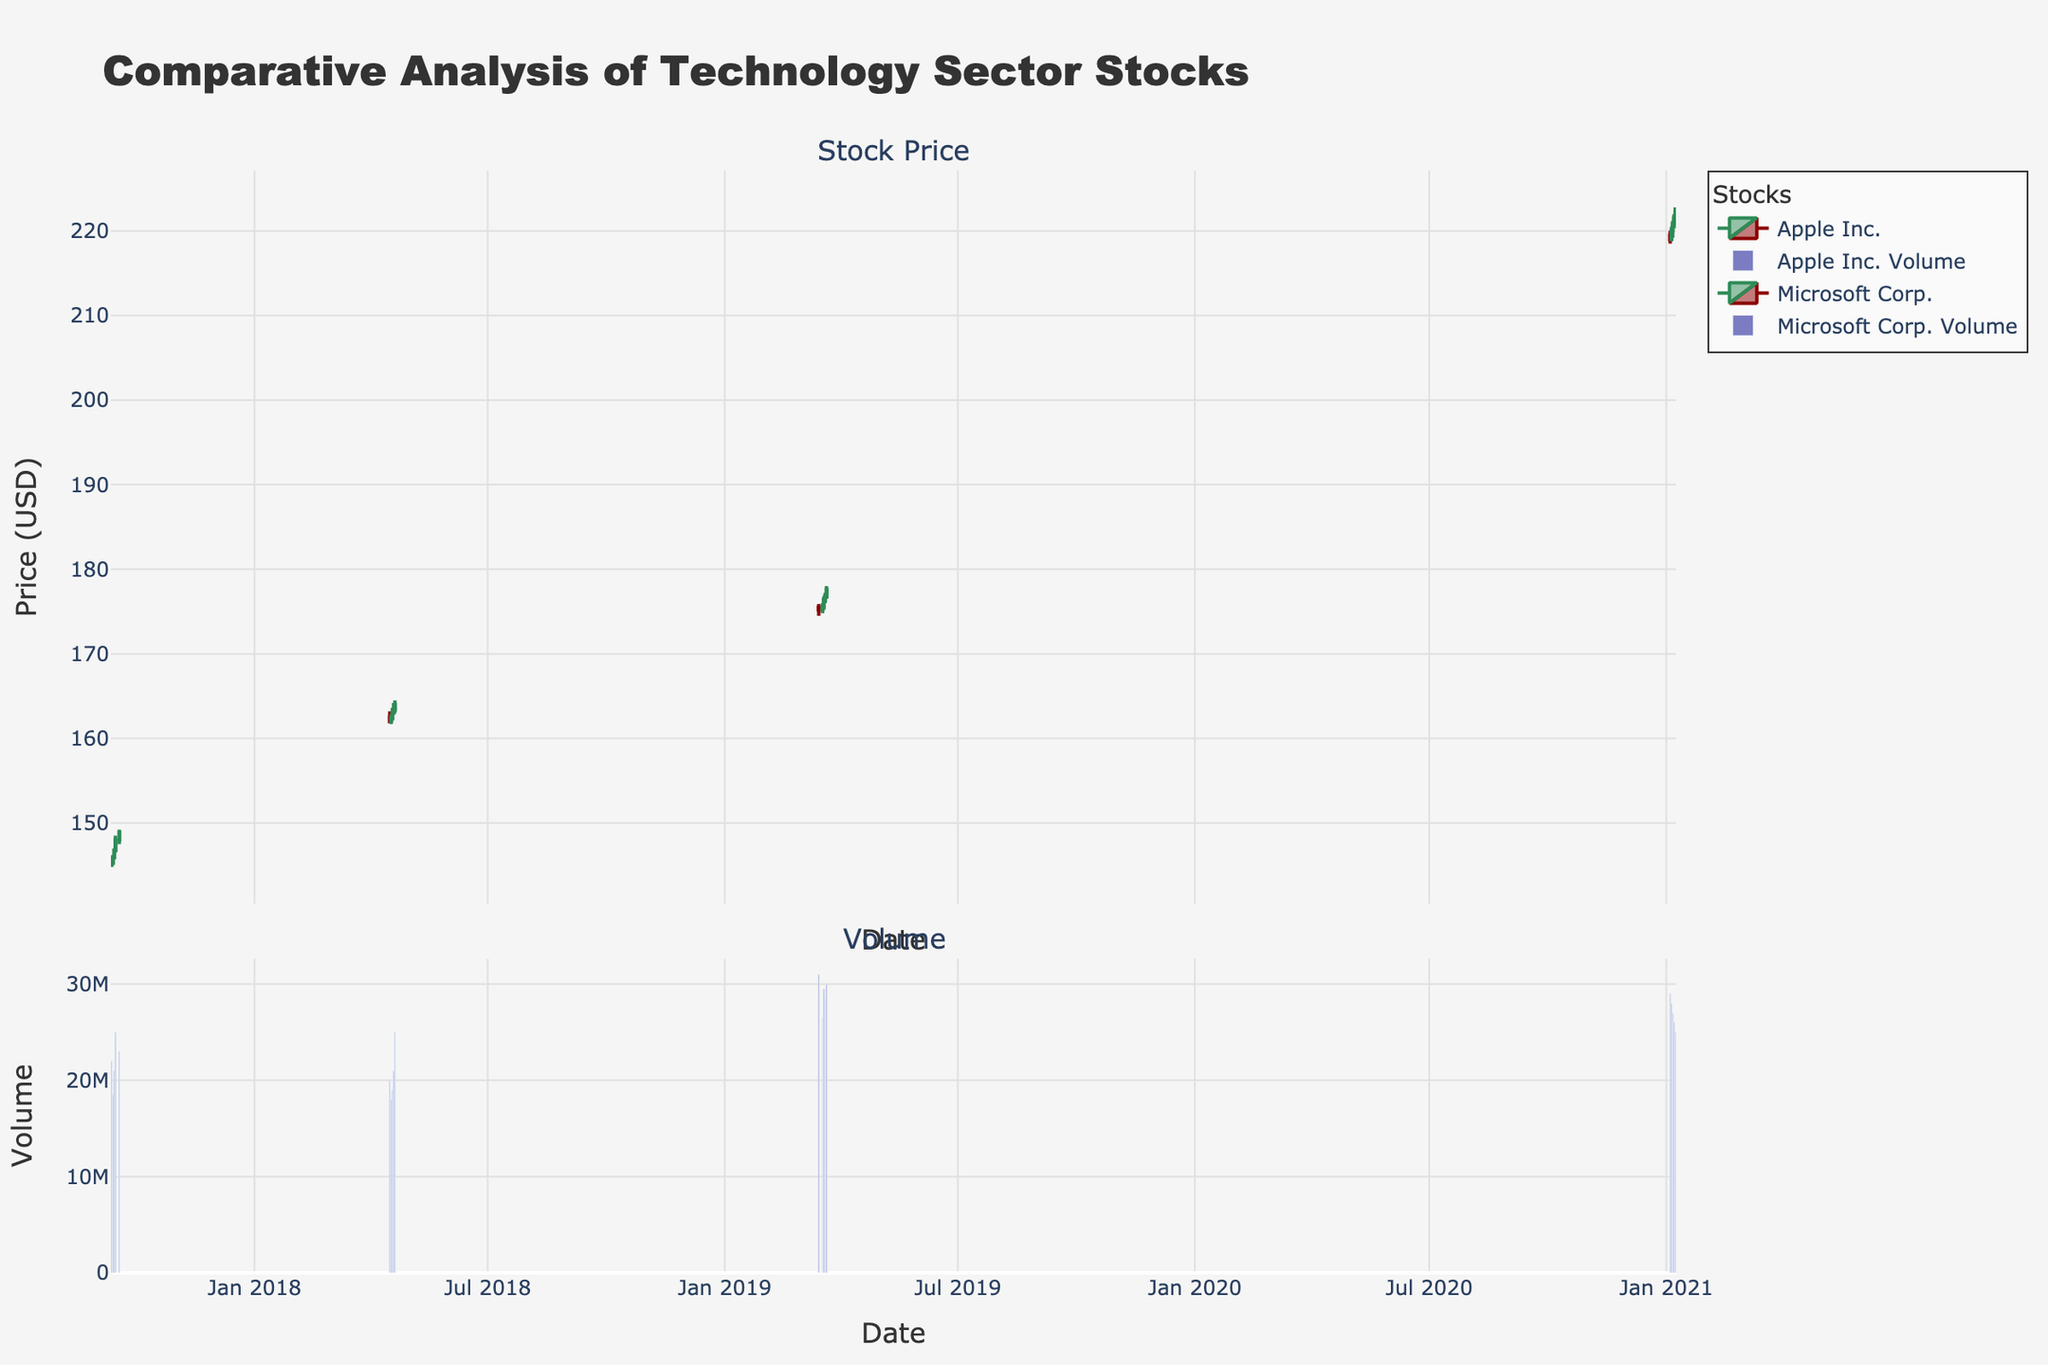What is the title of the figure? The title is located at the top of the figure. This provides an overall idea about the data being visualized. The title here is "Comparative Analysis of Technology Sector Stocks".
Answer: Comparative Analysis of Technology Sector Stocks How many stocks are compared in this plot? The plot includes two stocks: Apple Inc. and Microsoft Corp., as can be seen in the legend section of the plot.
Answer: 2 During what time periods did Apple Inc. and Microsoft Corp.'s stocks overlap in the plot? By observing the x-axes of the candlestick charts, we notice that Apple Inc.'s stock data is from 2017 and 2019, while Microsoft Corp.'s stock data is from 2018 and 2021. There is no overlap time period where both stocks appear simultaneously.
Answer: No overlap What is the date range of data for Microsoft Corp.? The x-axis indicates the date range of the data. For Microsoft Corp., data points are recorded from April 16, 2018, to January 8, 2021.
Answer: April 16, 2018, to January 8, 2021 Which stock had the higher closing price on January 8, 2021? Reviewing the candlesticks for the specific date of January 8, 2021, for Microsoft Corp., which is displayed on the candlestick chart, can confirm the closing price. Since only Microsoft Corp's data is present for that date, it had the higher closing price.
Answer: Microsoft Corp How often did Apple's stock price increase consecutively in the provided data? To answer this, we need to look at the close prices for consecutive days. Apple Inc.'s stock prices increased consecutively on two occasions: from September 12, 2017, to September 15, 2017 (4 days), and from March 15, 2019, to March 21, 2019 (5 days).
Answer: 2 occasions Which stock had more volume traded on April 18, 2018? The bar chart in the second subplot shows the trading volume. By finding the corresponding bar for April 18, 2018, we see that only Microsoft Corp. has data for this date. Hence, Microsoft Corp. had more volume traded.
Answer: Microsoft Corp What is the lowest closing price for Apple Inc. in the dataset? The lowest closing price can be identified by scanning the close prices for Apple Inc. from the candlestick chart. The lowest is $145.30 on September 12, 2017.
Answer: $145.30 How does the trading volume compare between Apple Inc. on September 15, 2017, and Microsoft Corp. on January 4, 2021? By examining the volume bars on both dates, Apple Inc. on September 15, 2017, had a volume of 25 million, while Microsoft Corp. on January 4, 2021, had a volume of 29 million. Microsoft Corp. had a higher trading volume on those specific dates.
Answer: Microsoft Corp. had a higher volume What was Apple Inc.'s highest high price in March 2019? We need to check the high prices for the days in March 2019 for Apple Inc. in the candlesticks. The highest high price was $178.00 on March 21, 2019.
Answer: $178.00 